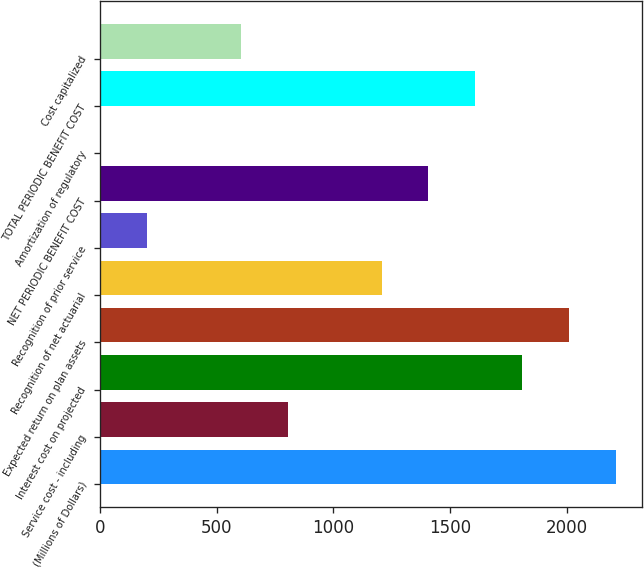Convert chart. <chart><loc_0><loc_0><loc_500><loc_500><bar_chart><fcel>(Millions of Dollars)<fcel>Service cost - including<fcel>Interest cost on projected<fcel>Expected return on plan assets<fcel>Recognition of net actuarial<fcel>Recognition of prior service<fcel>NET PERIODIC BENEFIT COST<fcel>Amortization of regulatory<fcel>TOTAL PERIODIC BENEFIT COST<fcel>Cost capitalized<nl><fcel>2210.8<fcel>805.2<fcel>1809.2<fcel>2010<fcel>1206.8<fcel>202.8<fcel>1407.6<fcel>2<fcel>1608.4<fcel>604.4<nl></chart> 